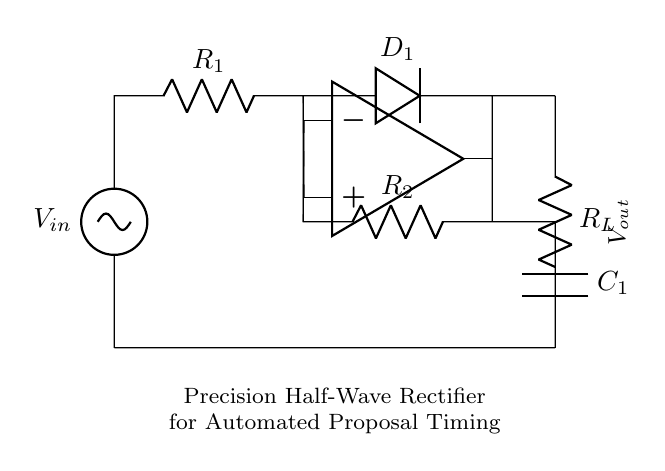What is the input voltage of the circuit? The circuit shows a voltage source labeled V_in, indicating the input voltage provided to the circuit.
Answer: V_in What component is used for rectification? The diode labeled D_1 is used for rectification, allowing current to flow in one direction only.
Answer: D_1 How many resistors are present in the circuit? There are two resistors labeled R_1 and R_2, which indicates the presence of two resistors in the circuit.
Answer: 2 What is the function of capacitor C_1 in the circuit? The capacitor C_1 is used for smoothing the output voltage by storing charge, which helps to reduce fluctuations.
Answer: Smoothing What will happen to the output voltage when the input voltage is negative? When the input voltage is negative, D_1 will block the current flow, resulting in no output voltage; hence V_out will be zero.
Answer: Zero Why is an operational amplifier used in this circuit? The operational amplifier is used to amplify the input signal and ensure high accuracy in the rectification process, especially under low voltage conditions.
Answer: Amplification What is the load resistor labeled in the diagram? The load resistor is labeled R_L, which is connected to the output and represents the load that the rectified voltage must drive.
Answer: R_L 